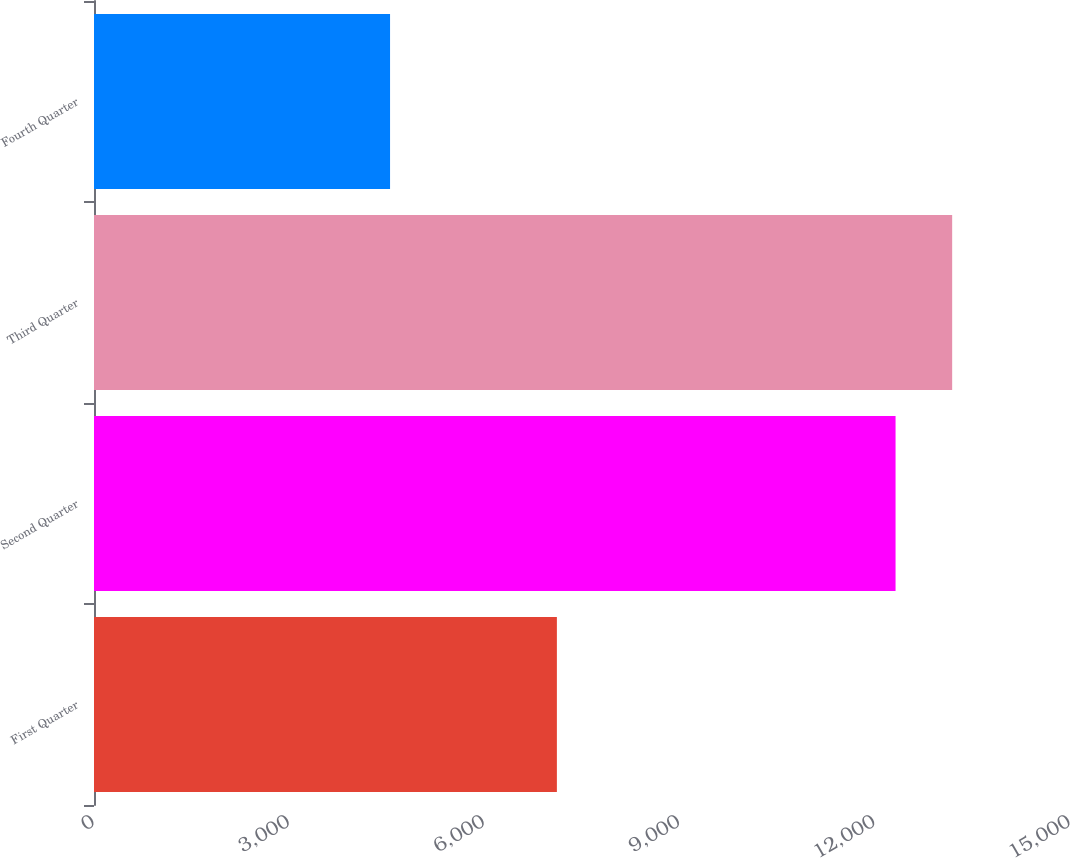<chart> <loc_0><loc_0><loc_500><loc_500><bar_chart><fcel>First Quarter<fcel>Second Quarter<fcel>Third Quarter<fcel>Fourth Quarter<nl><fcel>7114<fcel>12319<fcel>13189<fcel>4550<nl></chart> 